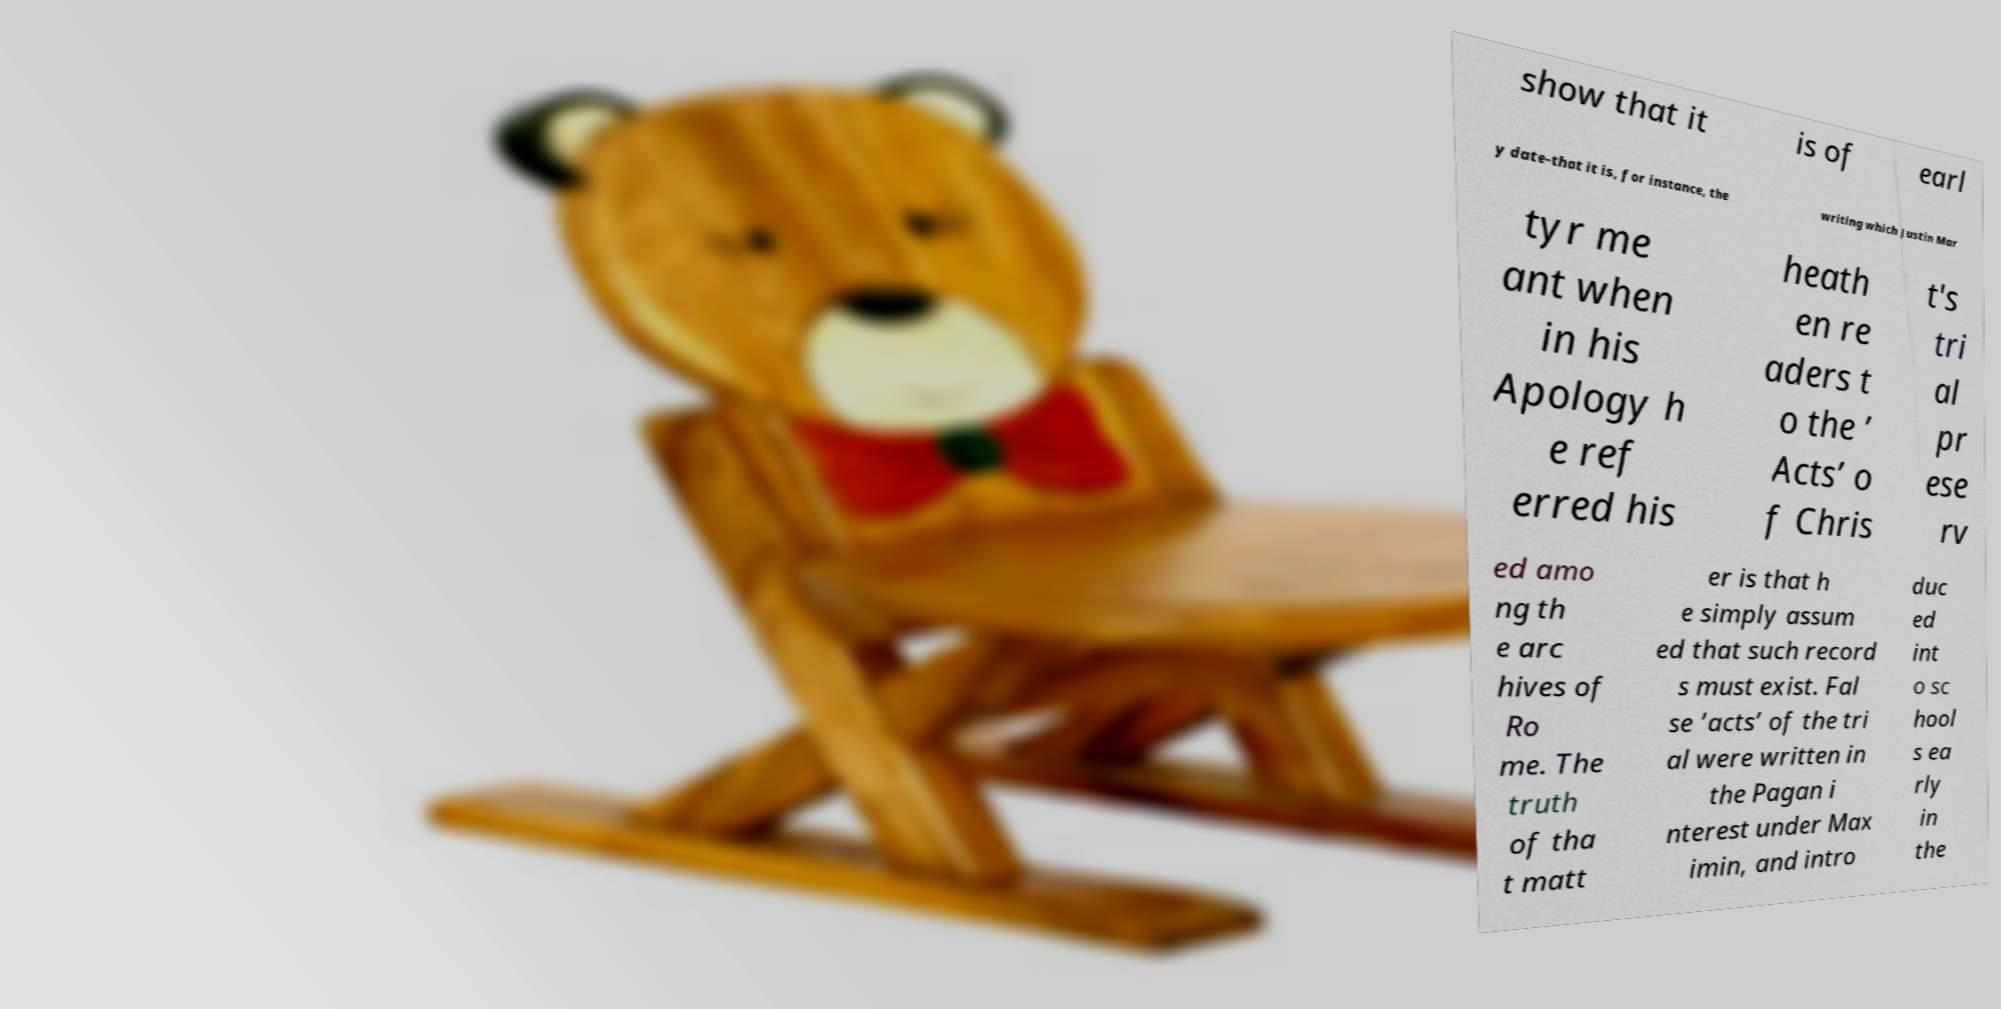I need the written content from this picture converted into text. Can you do that? show that it is of earl y date-that it is, for instance, the writing which Justin Mar tyr me ant when in his Apology h e ref erred his heath en re aders t o the ’ Acts’ o f Chris t's tri al pr ese rv ed amo ng th e arc hives of Ro me. The truth of tha t matt er is that h e simply assum ed that such record s must exist. Fal se ’acts’ of the tri al were written in the Pagan i nterest under Max imin, and intro duc ed int o sc hool s ea rly in the 